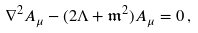<formula> <loc_0><loc_0><loc_500><loc_500>\nabla ^ { 2 } A _ { \mu } - ( 2 \Lambda + \mathfrak { m } ^ { 2 } ) A _ { \mu } = 0 \, ,</formula> 